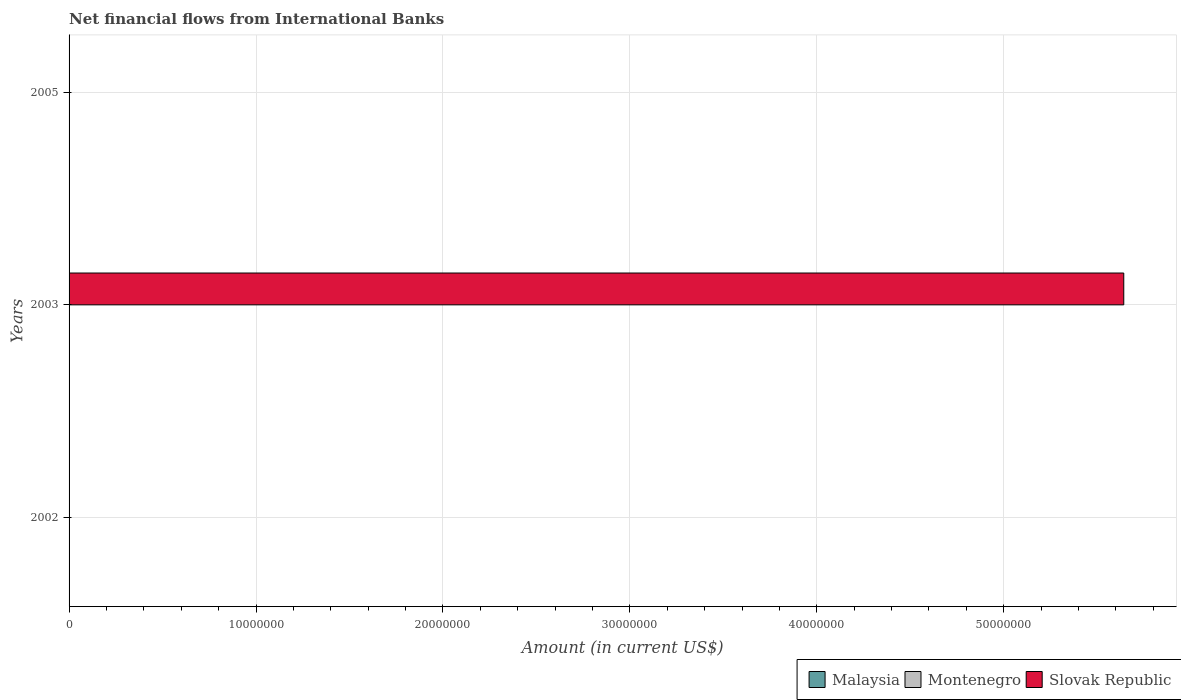How many different coloured bars are there?
Make the answer very short. 1. Are the number of bars on each tick of the Y-axis equal?
Offer a very short reply. No. How many bars are there on the 2nd tick from the bottom?
Offer a very short reply. 1. In how many cases, is the number of bars for a given year not equal to the number of legend labels?
Your response must be concise. 3. Across all years, what is the minimum net financial aid flows in Malaysia?
Give a very brief answer. 0. In which year was the net financial aid flows in Slovak Republic maximum?
Your answer should be very brief. 2003. What is the difference between the net financial aid flows in Montenegro in 2005 and the net financial aid flows in Slovak Republic in 2003?
Ensure brevity in your answer.  -5.64e+07. What is the average net financial aid flows in Slovak Republic per year?
Offer a very short reply. 1.88e+07. In how many years, is the net financial aid flows in Malaysia greater than 14000000 US$?
Give a very brief answer. 0. What is the difference between the highest and the lowest net financial aid flows in Slovak Republic?
Provide a short and direct response. 5.64e+07. How many bars are there?
Give a very brief answer. 1. Are all the bars in the graph horizontal?
Offer a terse response. Yes. How many years are there in the graph?
Provide a succinct answer. 3. Does the graph contain any zero values?
Ensure brevity in your answer.  Yes. What is the title of the graph?
Keep it short and to the point. Net financial flows from International Banks. Does "French Polynesia" appear as one of the legend labels in the graph?
Give a very brief answer. No. What is the label or title of the X-axis?
Provide a short and direct response. Amount (in current US$). What is the Amount (in current US$) in Montenegro in 2002?
Your answer should be compact. 0. What is the Amount (in current US$) in Slovak Republic in 2002?
Your answer should be compact. 0. What is the Amount (in current US$) in Slovak Republic in 2003?
Make the answer very short. 5.64e+07. What is the Amount (in current US$) in Slovak Republic in 2005?
Offer a terse response. 0. Across all years, what is the maximum Amount (in current US$) in Slovak Republic?
Your response must be concise. 5.64e+07. Across all years, what is the minimum Amount (in current US$) of Slovak Republic?
Provide a short and direct response. 0. What is the total Amount (in current US$) in Malaysia in the graph?
Offer a terse response. 0. What is the total Amount (in current US$) of Montenegro in the graph?
Keep it short and to the point. 0. What is the total Amount (in current US$) in Slovak Republic in the graph?
Provide a short and direct response. 5.64e+07. What is the average Amount (in current US$) in Montenegro per year?
Give a very brief answer. 0. What is the average Amount (in current US$) of Slovak Republic per year?
Provide a short and direct response. 1.88e+07. What is the difference between the highest and the lowest Amount (in current US$) in Slovak Republic?
Offer a very short reply. 5.64e+07. 